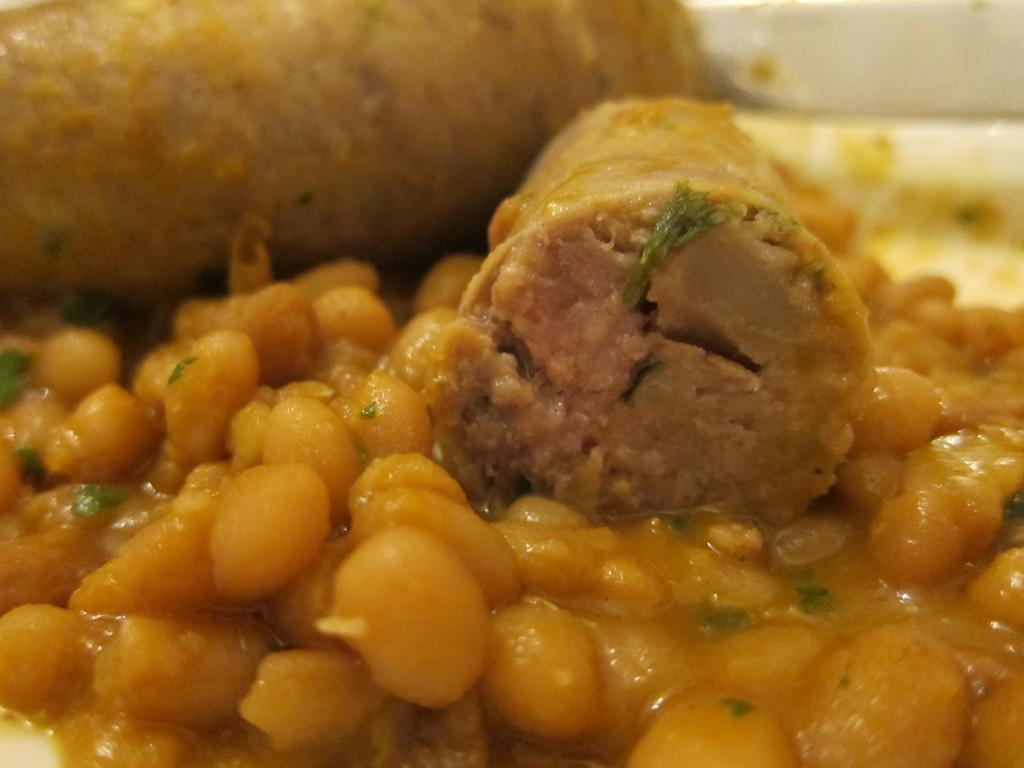What is the main subject of the image? The main subject of the image is food. Can you describe the appearance of the food? The food has a lite yellow color. How is the food arranged in the image? The food is in a plate. What is the color of the plate? The plate is white in color. Is there a spy hiding in the bushes in the image? There is no mention of bushes or a spy in the image. 